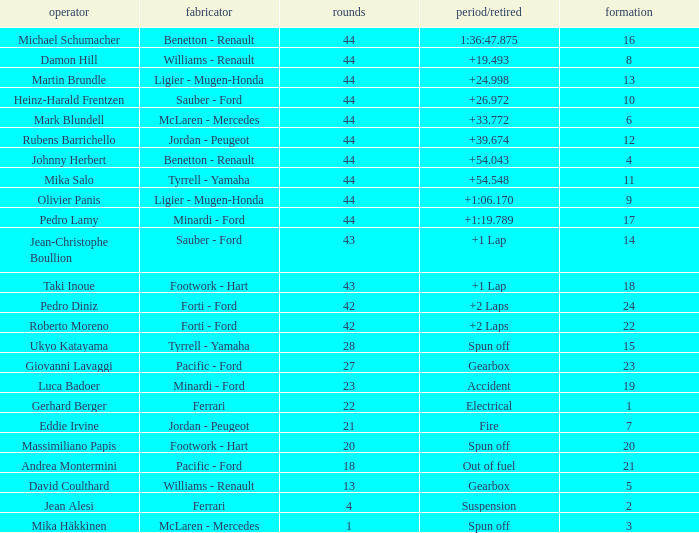Who built the car that ran out of fuel before 28 laps? Pacific - Ford. 